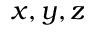Convert formula to latex. <formula><loc_0><loc_0><loc_500><loc_500>x , y , z</formula> 